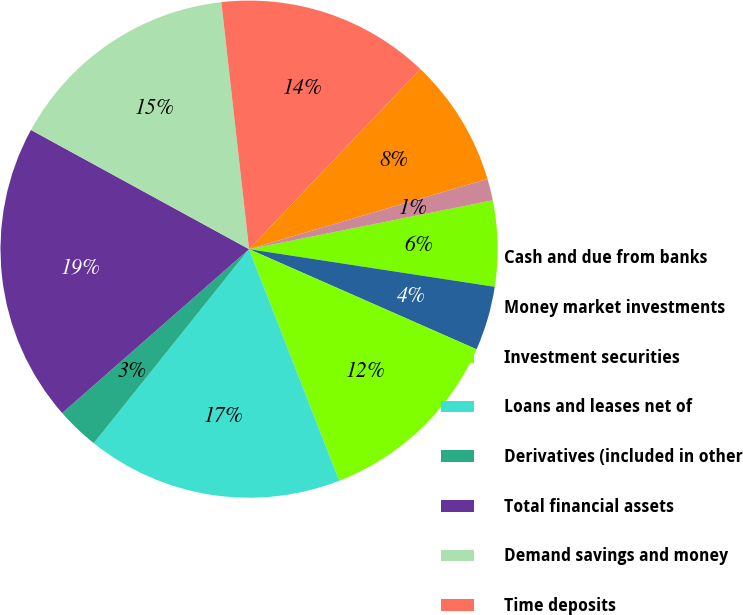Convert chart. <chart><loc_0><loc_0><loc_500><loc_500><pie_chart><fcel>Cash and due from banks<fcel>Money market investments<fcel>Investment securities<fcel>Loans and leases net of<fcel>Derivatives (included in other<fcel>Total financial assets<fcel>Demand savings and money<fcel>Time deposits<fcel>Foreign deposits<fcel>Securities sold not yet<nl><fcel>5.57%<fcel>4.18%<fcel>12.49%<fcel>16.65%<fcel>2.8%<fcel>19.42%<fcel>15.26%<fcel>13.88%<fcel>8.34%<fcel>1.41%<nl></chart> 